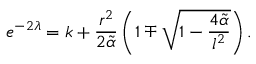Convert formula to latex. <formula><loc_0><loc_0><loc_500><loc_500>e ^ { - 2 \lambda } = k + \frac { r ^ { 2 } } { 2 \tilde { \alpha } } \left ( 1 \mp \sqrt { 1 - \frac { 4 \tilde { \alpha } } { l ^ { 2 } } } \right ) .</formula> 